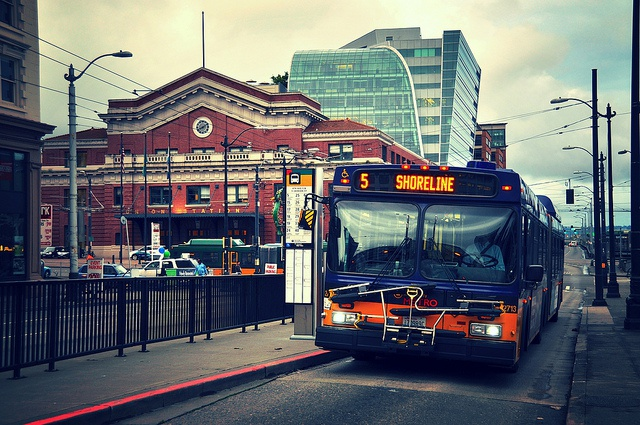Describe the objects in this image and their specific colors. I can see bus in black, navy, gray, and blue tones, people in black, blue, navy, and teal tones, car in black, ivory, navy, and darkgray tones, clock in black, khaki, lightyellow, gray, and darkgray tones, and car in black, ivory, navy, and blue tones in this image. 